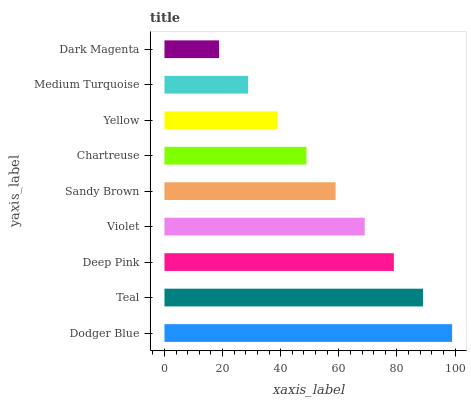Is Dark Magenta the minimum?
Answer yes or no. Yes. Is Dodger Blue the maximum?
Answer yes or no. Yes. Is Teal the minimum?
Answer yes or no. No. Is Teal the maximum?
Answer yes or no. No. Is Dodger Blue greater than Teal?
Answer yes or no. Yes. Is Teal less than Dodger Blue?
Answer yes or no. Yes. Is Teal greater than Dodger Blue?
Answer yes or no. No. Is Dodger Blue less than Teal?
Answer yes or no. No. Is Sandy Brown the high median?
Answer yes or no. Yes. Is Sandy Brown the low median?
Answer yes or no. Yes. Is Deep Pink the high median?
Answer yes or no. No. Is Violet the low median?
Answer yes or no. No. 